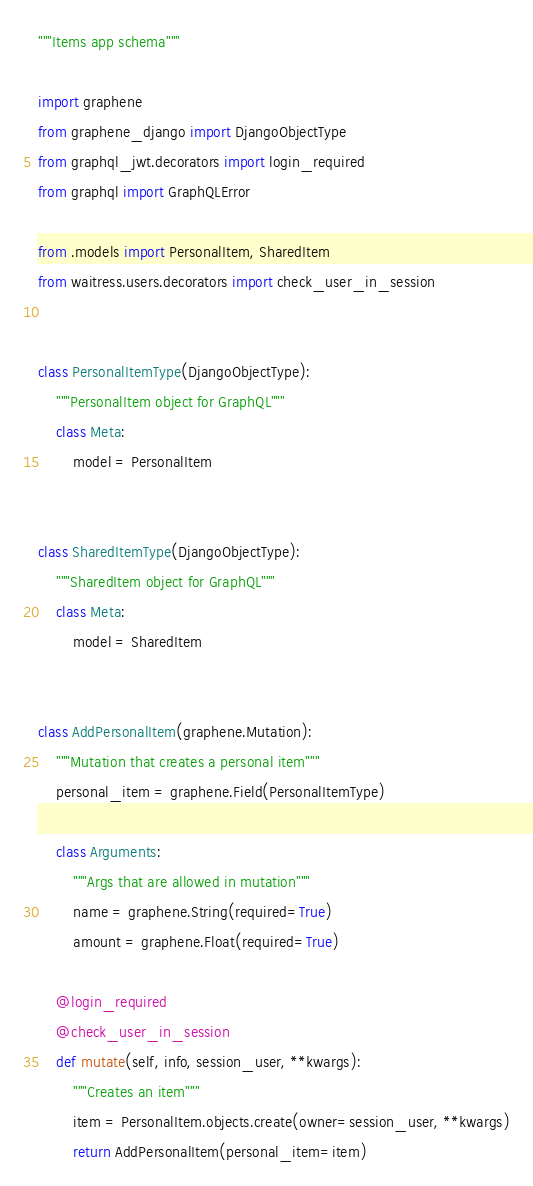Convert code to text. <code><loc_0><loc_0><loc_500><loc_500><_Python_>"""Items app schema"""

import graphene
from graphene_django import DjangoObjectType
from graphql_jwt.decorators import login_required
from graphql import GraphQLError

from .models import PersonalItem, SharedItem
from waitress.users.decorators import check_user_in_session


class PersonalItemType(DjangoObjectType):
    """PersonalItem object for GraphQL"""
    class Meta:
        model = PersonalItem


class SharedItemType(DjangoObjectType):
    """SharedItem object for GraphQL"""
    class Meta:
        model = SharedItem


class AddPersonalItem(graphene.Mutation):
    """Mutation that creates a personal item"""
    personal_item = graphene.Field(PersonalItemType)

    class Arguments:
        """Args that are allowed in mutation"""
        name = graphene.String(required=True)
        amount = graphene.Float(required=True)

    @login_required
    @check_user_in_session
    def mutate(self, info, session_user, **kwargs):
        """Creates an item"""
        item = PersonalItem.objects.create(owner=session_user, **kwargs)
        return AddPersonalItem(personal_item=item)

</code> 